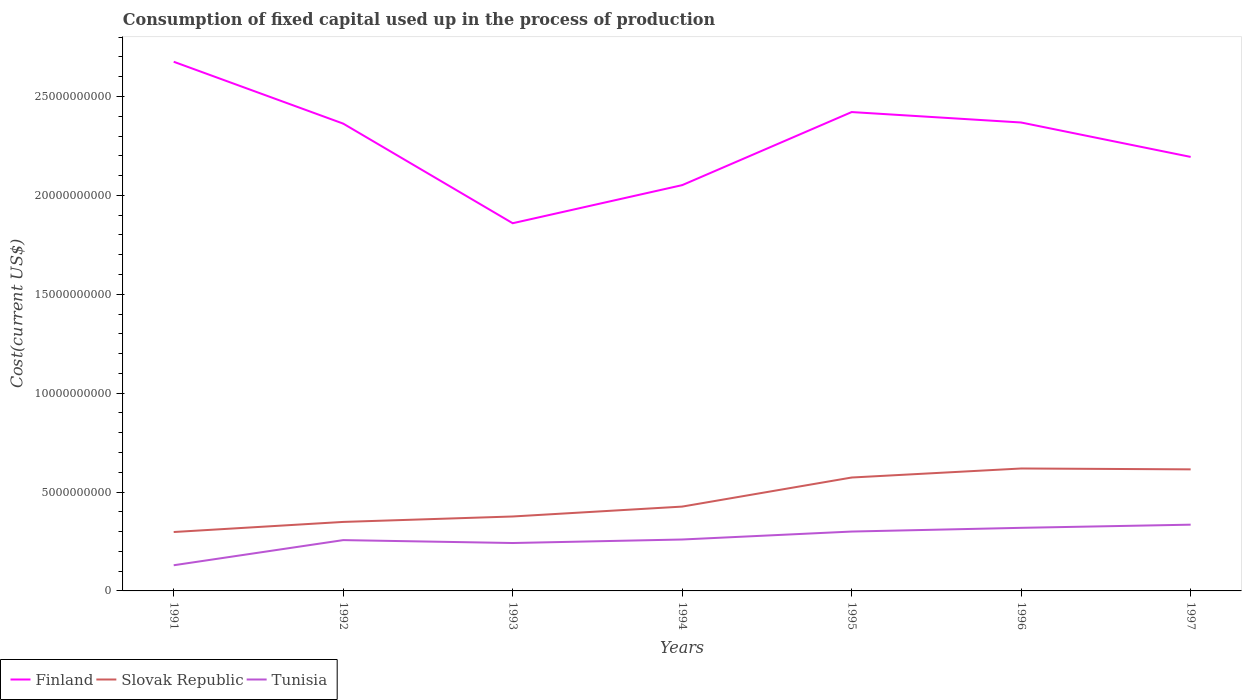Across all years, what is the maximum amount consumed in the process of production in Finland?
Your answer should be compact. 1.86e+1. What is the total amount consumed in the process of production in Finland in the graph?
Offer a terse response. -5.59e+07. What is the difference between the highest and the second highest amount consumed in the process of production in Slovak Republic?
Keep it short and to the point. 3.21e+09. Is the amount consumed in the process of production in Finland strictly greater than the amount consumed in the process of production in Tunisia over the years?
Give a very brief answer. No. What is the difference between two consecutive major ticks on the Y-axis?
Provide a succinct answer. 5.00e+09. Are the values on the major ticks of Y-axis written in scientific E-notation?
Your answer should be compact. No. How many legend labels are there?
Your answer should be compact. 3. How are the legend labels stacked?
Your response must be concise. Horizontal. What is the title of the graph?
Your response must be concise. Consumption of fixed capital used up in the process of production. What is the label or title of the Y-axis?
Provide a succinct answer. Cost(current US$). What is the Cost(current US$) in Finland in 1991?
Offer a terse response. 2.68e+1. What is the Cost(current US$) of Slovak Republic in 1991?
Your response must be concise. 2.98e+09. What is the Cost(current US$) of Tunisia in 1991?
Make the answer very short. 1.30e+09. What is the Cost(current US$) of Finland in 1992?
Ensure brevity in your answer.  2.36e+1. What is the Cost(current US$) in Slovak Republic in 1992?
Give a very brief answer. 3.49e+09. What is the Cost(current US$) of Tunisia in 1992?
Your answer should be very brief. 2.57e+09. What is the Cost(current US$) in Finland in 1993?
Provide a succinct answer. 1.86e+1. What is the Cost(current US$) in Slovak Republic in 1993?
Provide a short and direct response. 3.76e+09. What is the Cost(current US$) of Tunisia in 1993?
Offer a very short reply. 2.42e+09. What is the Cost(current US$) of Finland in 1994?
Make the answer very short. 2.05e+1. What is the Cost(current US$) of Slovak Republic in 1994?
Your answer should be compact. 4.26e+09. What is the Cost(current US$) of Tunisia in 1994?
Offer a terse response. 2.60e+09. What is the Cost(current US$) of Finland in 1995?
Make the answer very short. 2.42e+1. What is the Cost(current US$) in Slovak Republic in 1995?
Your answer should be very brief. 5.73e+09. What is the Cost(current US$) in Tunisia in 1995?
Give a very brief answer. 3.00e+09. What is the Cost(current US$) in Finland in 1996?
Offer a very short reply. 2.37e+1. What is the Cost(current US$) in Slovak Republic in 1996?
Your answer should be very brief. 6.19e+09. What is the Cost(current US$) in Tunisia in 1996?
Offer a terse response. 3.19e+09. What is the Cost(current US$) in Finland in 1997?
Keep it short and to the point. 2.19e+1. What is the Cost(current US$) of Slovak Republic in 1997?
Provide a succinct answer. 6.15e+09. What is the Cost(current US$) in Tunisia in 1997?
Provide a succinct answer. 3.35e+09. Across all years, what is the maximum Cost(current US$) in Finland?
Keep it short and to the point. 2.68e+1. Across all years, what is the maximum Cost(current US$) of Slovak Republic?
Your response must be concise. 6.19e+09. Across all years, what is the maximum Cost(current US$) of Tunisia?
Your response must be concise. 3.35e+09. Across all years, what is the minimum Cost(current US$) of Finland?
Give a very brief answer. 1.86e+1. Across all years, what is the minimum Cost(current US$) in Slovak Republic?
Provide a succinct answer. 2.98e+09. Across all years, what is the minimum Cost(current US$) of Tunisia?
Provide a short and direct response. 1.30e+09. What is the total Cost(current US$) of Finland in the graph?
Offer a terse response. 1.59e+11. What is the total Cost(current US$) of Slovak Republic in the graph?
Your response must be concise. 3.26e+1. What is the total Cost(current US$) of Tunisia in the graph?
Offer a very short reply. 1.84e+1. What is the difference between the Cost(current US$) in Finland in 1991 and that in 1992?
Offer a very short reply. 3.13e+09. What is the difference between the Cost(current US$) in Slovak Republic in 1991 and that in 1992?
Your response must be concise. -5.11e+08. What is the difference between the Cost(current US$) in Tunisia in 1991 and that in 1992?
Offer a very short reply. -1.27e+09. What is the difference between the Cost(current US$) in Finland in 1991 and that in 1993?
Offer a very short reply. 8.16e+09. What is the difference between the Cost(current US$) of Slovak Republic in 1991 and that in 1993?
Your answer should be compact. -7.86e+08. What is the difference between the Cost(current US$) in Tunisia in 1991 and that in 1993?
Provide a short and direct response. -1.12e+09. What is the difference between the Cost(current US$) in Finland in 1991 and that in 1994?
Your response must be concise. 6.24e+09. What is the difference between the Cost(current US$) in Slovak Republic in 1991 and that in 1994?
Offer a terse response. -1.29e+09. What is the difference between the Cost(current US$) in Tunisia in 1991 and that in 1994?
Ensure brevity in your answer.  -1.30e+09. What is the difference between the Cost(current US$) in Finland in 1991 and that in 1995?
Make the answer very short. 2.54e+09. What is the difference between the Cost(current US$) in Slovak Republic in 1991 and that in 1995?
Your response must be concise. -2.76e+09. What is the difference between the Cost(current US$) in Tunisia in 1991 and that in 1995?
Ensure brevity in your answer.  -1.70e+09. What is the difference between the Cost(current US$) in Finland in 1991 and that in 1996?
Give a very brief answer. 3.07e+09. What is the difference between the Cost(current US$) of Slovak Republic in 1991 and that in 1996?
Keep it short and to the point. -3.21e+09. What is the difference between the Cost(current US$) of Tunisia in 1991 and that in 1996?
Give a very brief answer. -1.89e+09. What is the difference between the Cost(current US$) of Finland in 1991 and that in 1997?
Your response must be concise. 4.81e+09. What is the difference between the Cost(current US$) of Slovak Republic in 1991 and that in 1997?
Offer a terse response. -3.17e+09. What is the difference between the Cost(current US$) of Tunisia in 1991 and that in 1997?
Your answer should be very brief. -2.05e+09. What is the difference between the Cost(current US$) in Finland in 1992 and that in 1993?
Provide a succinct answer. 5.04e+09. What is the difference between the Cost(current US$) of Slovak Republic in 1992 and that in 1993?
Your answer should be compact. -2.75e+08. What is the difference between the Cost(current US$) of Tunisia in 1992 and that in 1993?
Give a very brief answer. 1.47e+08. What is the difference between the Cost(current US$) of Finland in 1992 and that in 1994?
Your answer should be compact. 3.11e+09. What is the difference between the Cost(current US$) of Slovak Republic in 1992 and that in 1994?
Ensure brevity in your answer.  -7.75e+08. What is the difference between the Cost(current US$) in Tunisia in 1992 and that in 1994?
Keep it short and to the point. -3.14e+07. What is the difference between the Cost(current US$) of Finland in 1992 and that in 1995?
Your answer should be compact. -5.84e+08. What is the difference between the Cost(current US$) in Slovak Republic in 1992 and that in 1995?
Ensure brevity in your answer.  -2.25e+09. What is the difference between the Cost(current US$) of Tunisia in 1992 and that in 1995?
Give a very brief answer. -4.33e+08. What is the difference between the Cost(current US$) in Finland in 1992 and that in 1996?
Your answer should be compact. -5.59e+07. What is the difference between the Cost(current US$) of Slovak Republic in 1992 and that in 1996?
Provide a succinct answer. -2.70e+09. What is the difference between the Cost(current US$) in Tunisia in 1992 and that in 1996?
Keep it short and to the point. -6.21e+08. What is the difference between the Cost(current US$) of Finland in 1992 and that in 1997?
Keep it short and to the point. 1.68e+09. What is the difference between the Cost(current US$) of Slovak Republic in 1992 and that in 1997?
Provide a succinct answer. -2.66e+09. What is the difference between the Cost(current US$) in Tunisia in 1992 and that in 1997?
Ensure brevity in your answer.  -7.81e+08. What is the difference between the Cost(current US$) in Finland in 1993 and that in 1994?
Offer a terse response. -1.93e+09. What is the difference between the Cost(current US$) of Slovak Republic in 1993 and that in 1994?
Your response must be concise. -5.00e+08. What is the difference between the Cost(current US$) of Tunisia in 1993 and that in 1994?
Your response must be concise. -1.78e+08. What is the difference between the Cost(current US$) in Finland in 1993 and that in 1995?
Ensure brevity in your answer.  -5.62e+09. What is the difference between the Cost(current US$) in Slovak Republic in 1993 and that in 1995?
Your answer should be very brief. -1.97e+09. What is the difference between the Cost(current US$) in Tunisia in 1993 and that in 1995?
Provide a short and direct response. -5.80e+08. What is the difference between the Cost(current US$) of Finland in 1993 and that in 1996?
Your answer should be compact. -5.09e+09. What is the difference between the Cost(current US$) of Slovak Republic in 1993 and that in 1996?
Give a very brief answer. -2.43e+09. What is the difference between the Cost(current US$) in Tunisia in 1993 and that in 1996?
Offer a very short reply. -7.68e+08. What is the difference between the Cost(current US$) in Finland in 1993 and that in 1997?
Provide a succinct answer. -3.35e+09. What is the difference between the Cost(current US$) of Slovak Republic in 1993 and that in 1997?
Keep it short and to the point. -2.38e+09. What is the difference between the Cost(current US$) in Tunisia in 1993 and that in 1997?
Offer a very short reply. -9.28e+08. What is the difference between the Cost(current US$) in Finland in 1994 and that in 1995?
Offer a very short reply. -3.69e+09. What is the difference between the Cost(current US$) in Slovak Republic in 1994 and that in 1995?
Your answer should be very brief. -1.47e+09. What is the difference between the Cost(current US$) in Tunisia in 1994 and that in 1995?
Keep it short and to the point. -4.02e+08. What is the difference between the Cost(current US$) in Finland in 1994 and that in 1996?
Ensure brevity in your answer.  -3.17e+09. What is the difference between the Cost(current US$) in Slovak Republic in 1994 and that in 1996?
Offer a very short reply. -1.93e+09. What is the difference between the Cost(current US$) in Tunisia in 1994 and that in 1996?
Your answer should be compact. -5.90e+08. What is the difference between the Cost(current US$) of Finland in 1994 and that in 1997?
Offer a terse response. -1.43e+09. What is the difference between the Cost(current US$) in Slovak Republic in 1994 and that in 1997?
Make the answer very short. -1.88e+09. What is the difference between the Cost(current US$) in Tunisia in 1994 and that in 1997?
Provide a short and direct response. -7.49e+08. What is the difference between the Cost(current US$) in Finland in 1995 and that in 1996?
Provide a succinct answer. 5.28e+08. What is the difference between the Cost(current US$) in Slovak Republic in 1995 and that in 1996?
Offer a terse response. -4.56e+08. What is the difference between the Cost(current US$) of Tunisia in 1995 and that in 1996?
Offer a terse response. -1.88e+08. What is the difference between the Cost(current US$) of Finland in 1995 and that in 1997?
Your answer should be very brief. 2.27e+09. What is the difference between the Cost(current US$) of Slovak Republic in 1995 and that in 1997?
Ensure brevity in your answer.  -4.12e+08. What is the difference between the Cost(current US$) of Tunisia in 1995 and that in 1997?
Make the answer very short. -3.47e+08. What is the difference between the Cost(current US$) in Finland in 1996 and that in 1997?
Your response must be concise. 1.74e+09. What is the difference between the Cost(current US$) of Slovak Republic in 1996 and that in 1997?
Ensure brevity in your answer.  4.36e+07. What is the difference between the Cost(current US$) of Tunisia in 1996 and that in 1997?
Your answer should be compact. -1.59e+08. What is the difference between the Cost(current US$) in Finland in 1991 and the Cost(current US$) in Slovak Republic in 1992?
Make the answer very short. 2.33e+1. What is the difference between the Cost(current US$) in Finland in 1991 and the Cost(current US$) in Tunisia in 1992?
Keep it short and to the point. 2.42e+1. What is the difference between the Cost(current US$) of Slovak Republic in 1991 and the Cost(current US$) of Tunisia in 1992?
Your answer should be compact. 4.09e+08. What is the difference between the Cost(current US$) of Finland in 1991 and the Cost(current US$) of Slovak Republic in 1993?
Make the answer very short. 2.30e+1. What is the difference between the Cost(current US$) in Finland in 1991 and the Cost(current US$) in Tunisia in 1993?
Make the answer very short. 2.43e+1. What is the difference between the Cost(current US$) in Slovak Republic in 1991 and the Cost(current US$) in Tunisia in 1993?
Offer a very short reply. 5.56e+08. What is the difference between the Cost(current US$) in Finland in 1991 and the Cost(current US$) in Slovak Republic in 1994?
Offer a terse response. 2.25e+1. What is the difference between the Cost(current US$) of Finland in 1991 and the Cost(current US$) of Tunisia in 1994?
Provide a succinct answer. 2.42e+1. What is the difference between the Cost(current US$) of Slovak Republic in 1991 and the Cost(current US$) of Tunisia in 1994?
Your answer should be compact. 3.78e+08. What is the difference between the Cost(current US$) of Finland in 1991 and the Cost(current US$) of Slovak Republic in 1995?
Make the answer very short. 2.10e+1. What is the difference between the Cost(current US$) in Finland in 1991 and the Cost(current US$) in Tunisia in 1995?
Offer a terse response. 2.38e+1. What is the difference between the Cost(current US$) of Slovak Republic in 1991 and the Cost(current US$) of Tunisia in 1995?
Give a very brief answer. -2.42e+07. What is the difference between the Cost(current US$) in Finland in 1991 and the Cost(current US$) in Slovak Republic in 1996?
Your answer should be compact. 2.06e+1. What is the difference between the Cost(current US$) of Finland in 1991 and the Cost(current US$) of Tunisia in 1996?
Your answer should be very brief. 2.36e+1. What is the difference between the Cost(current US$) of Slovak Republic in 1991 and the Cost(current US$) of Tunisia in 1996?
Give a very brief answer. -2.12e+08. What is the difference between the Cost(current US$) in Finland in 1991 and the Cost(current US$) in Slovak Republic in 1997?
Offer a terse response. 2.06e+1. What is the difference between the Cost(current US$) of Finland in 1991 and the Cost(current US$) of Tunisia in 1997?
Provide a succinct answer. 2.34e+1. What is the difference between the Cost(current US$) in Slovak Republic in 1991 and the Cost(current US$) in Tunisia in 1997?
Ensure brevity in your answer.  -3.71e+08. What is the difference between the Cost(current US$) of Finland in 1992 and the Cost(current US$) of Slovak Republic in 1993?
Make the answer very short. 1.99e+1. What is the difference between the Cost(current US$) of Finland in 1992 and the Cost(current US$) of Tunisia in 1993?
Make the answer very short. 2.12e+1. What is the difference between the Cost(current US$) in Slovak Republic in 1992 and the Cost(current US$) in Tunisia in 1993?
Ensure brevity in your answer.  1.07e+09. What is the difference between the Cost(current US$) of Finland in 1992 and the Cost(current US$) of Slovak Republic in 1994?
Offer a very short reply. 1.94e+1. What is the difference between the Cost(current US$) in Finland in 1992 and the Cost(current US$) in Tunisia in 1994?
Your answer should be very brief. 2.10e+1. What is the difference between the Cost(current US$) of Slovak Republic in 1992 and the Cost(current US$) of Tunisia in 1994?
Your answer should be compact. 8.88e+08. What is the difference between the Cost(current US$) of Finland in 1992 and the Cost(current US$) of Slovak Republic in 1995?
Give a very brief answer. 1.79e+1. What is the difference between the Cost(current US$) of Finland in 1992 and the Cost(current US$) of Tunisia in 1995?
Ensure brevity in your answer.  2.06e+1. What is the difference between the Cost(current US$) in Slovak Republic in 1992 and the Cost(current US$) in Tunisia in 1995?
Your answer should be very brief. 4.86e+08. What is the difference between the Cost(current US$) of Finland in 1992 and the Cost(current US$) of Slovak Republic in 1996?
Provide a short and direct response. 1.74e+1. What is the difference between the Cost(current US$) in Finland in 1992 and the Cost(current US$) in Tunisia in 1996?
Your answer should be very brief. 2.04e+1. What is the difference between the Cost(current US$) of Slovak Republic in 1992 and the Cost(current US$) of Tunisia in 1996?
Provide a short and direct response. 2.99e+08. What is the difference between the Cost(current US$) in Finland in 1992 and the Cost(current US$) in Slovak Republic in 1997?
Ensure brevity in your answer.  1.75e+1. What is the difference between the Cost(current US$) in Finland in 1992 and the Cost(current US$) in Tunisia in 1997?
Give a very brief answer. 2.03e+1. What is the difference between the Cost(current US$) in Slovak Republic in 1992 and the Cost(current US$) in Tunisia in 1997?
Your response must be concise. 1.39e+08. What is the difference between the Cost(current US$) in Finland in 1993 and the Cost(current US$) in Slovak Republic in 1994?
Provide a short and direct response. 1.43e+1. What is the difference between the Cost(current US$) in Finland in 1993 and the Cost(current US$) in Tunisia in 1994?
Your answer should be compact. 1.60e+1. What is the difference between the Cost(current US$) in Slovak Republic in 1993 and the Cost(current US$) in Tunisia in 1994?
Offer a very short reply. 1.16e+09. What is the difference between the Cost(current US$) of Finland in 1993 and the Cost(current US$) of Slovak Republic in 1995?
Your answer should be very brief. 1.29e+1. What is the difference between the Cost(current US$) of Finland in 1993 and the Cost(current US$) of Tunisia in 1995?
Make the answer very short. 1.56e+1. What is the difference between the Cost(current US$) of Slovak Republic in 1993 and the Cost(current US$) of Tunisia in 1995?
Your response must be concise. 7.62e+08. What is the difference between the Cost(current US$) of Finland in 1993 and the Cost(current US$) of Slovak Republic in 1996?
Your answer should be very brief. 1.24e+1. What is the difference between the Cost(current US$) of Finland in 1993 and the Cost(current US$) of Tunisia in 1996?
Your answer should be very brief. 1.54e+1. What is the difference between the Cost(current US$) in Slovak Republic in 1993 and the Cost(current US$) in Tunisia in 1996?
Offer a terse response. 5.74e+08. What is the difference between the Cost(current US$) of Finland in 1993 and the Cost(current US$) of Slovak Republic in 1997?
Your answer should be compact. 1.24e+1. What is the difference between the Cost(current US$) in Finland in 1993 and the Cost(current US$) in Tunisia in 1997?
Provide a succinct answer. 1.52e+1. What is the difference between the Cost(current US$) in Slovak Republic in 1993 and the Cost(current US$) in Tunisia in 1997?
Give a very brief answer. 4.14e+08. What is the difference between the Cost(current US$) in Finland in 1994 and the Cost(current US$) in Slovak Republic in 1995?
Your response must be concise. 1.48e+1. What is the difference between the Cost(current US$) in Finland in 1994 and the Cost(current US$) in Tunisia in 1995?
Make the answer very short. 1.75e+1. What is the difference between the Cost(current US$) of Slovak Republic in 1994 and the Cost(current US$) of Tunisia in 1995?
Make the answer very short. 1.26e+09. What is the difference between the Cost(current US$) of Finland in 1994 and the Cost(current US$) of Slovak Republic in 1996?
Ensure brevity in your answer.  1.43e+1. What is the difference between the Cost(current US$) in Finland in 1994 and the Cost(current US$) in Tunisia in 1996?
Make the answer very short. 1.73e+1. What is the difference between the Cost(current US$) of Slovak Republic in 1994 and the Cost(current US$) of Tunisia in 1996?
Keep it short and to the point. 1.07e+09. What is the difference between the Cost(current US$) of Finland in 1994 and the Cost(current US$) of Slovak Republic in 1997?
Ensure brevity in your answer.  1.44e+1. What is the difference between the Cost(current US$) of Finland in 1994 and the Cost(current US$) of Tunisia in 1997?
Offer a terse response. 1.72e+1. What is the difference between the Cost(current US$) of Slovak Republic in 1994 and the Cost(current US$) of Tunisia in 1997?
Give a very brief answer. 9.14e+08. What is the difference between the Cost(current US$) in Finland in 1995 and the Cost(current US$) in Slovak Republic in 1996?
Your answer should be very brief. 1.80e+1. What is the difference between the Cost(current US$) of Finland in 1995 and the Cost(current US$) of Tunisia in 1996?
Make the answer very short. 2.10e+1. What is the difference between the Cost(current US$) of Slovak Republic in 1995 and the Cost(current US$) of Tunisia in 1996?
Make the answer very short. 2.54e+09. What is the difference between the Cost(current US$) in Finland in 1995 and the Cost(current US$) in Slovak Republic in 1997?
Provide a short and direct response. 1.81e+1. What is the difference between the Cost(current US$) in Finland in 1995 and the Cost(current US$) in Tunisia in 1997?
Offer a very short reply. 2.09e+1. What is the difference between the Cost(current US$) in Slovak Republic in 1995 and the Cost(current US$) in Tunisia in 1997?
Your answer should be very brief. 2.38e+09. What is the difference between the Cost(current US$) of Finland in 1996 and the Cost(current US$) of Slovak Republic in 1997?
Provide a short and direct response. 1.75e+1. What is the difference between the Cost(current US$) in Finland in 1996 and the Cost(current US$) in Tunisia in 1997?
Offer a terse response. 2.03e+1. What is the difference between the Cost(current US$) in Slovak Republic in 1996 and the Cost(current US$) in Tunisia in 1997?
Give a very brief answer. 2.84e+09. What is the average Cost(current US$) in Finland per year?
Your answer should be compact. 2.28e+1. What is the average Cost(current US$) of Slovak Republic per year?
Your response must be concise. 4.65e+09. What is the average Cost(current US$) of Tunisia per year?
Keep it short and to the point. 2.63e+09. In the year 1991, what is the difference between the Cost(current US$) in Finland and Cost(current US$) in Slovak Republic?
Offer a very short reply. 2.38e+1. In the year 1991, what is the difference between the Cost(current US$) in Finland and Cost(current US$) in Tunisia?
Keep it short and to the point. 2.55e+1. In the year 1991, what is the difference between the Cost(current US$) in Slovak Republic and Cost(current US$) in Tunisia?
Ensure brevity in your answer.  1.68e+09. In the year 1992, what is the difference between the Cost(current US$) of Finland and Cost(current US$) of Slovak Republic?
Make the answer very short. 2.01e+1. In the year 1992, what is the difference between the Cost(current US$) in Finland and Cost(current US$) in Tunisia?
Provide a succinct answer. 2.11e+1. In the year 1992, what is the difference between the Cost(current US$) of Slovak Republic and Cost(current US$) of Tunisia?
Offer a very short reply. 9.20e+08. In the year 1993, what is the difference between the Cost(current US$) of Finland and Cost(current US$) of Slovak Republic?
Provide a succinct answer. 1.48e+1. In the year 1993, what is the difference between the Cost(current US$) in Finland and Cost(current US$) in Tunisia?
Make the answer very short. 1.62e+1. In the year 1993, what is the difference between the Cost(current US$) of Slovak Republic and Cost(current US$) of Tunisia?
Offer a very short reply. 1.34e+09. In the year 1994, what is the difference between the Cost(current US$) in Finland and Cost(current US$) in Slovak Republic?
Your answer should be compact. 1.63e+1. In the year 1994, what is the difference between the Cost(current US$) in Finland and Cost(current US$) in Tunisia?
Provide a short and direct response. 1.79e+1. In the year 1994, what is the difference between the Cost(current US$) of Slovak Republic and Cost(current US$) of Tunisia?
Your answer should be compact. 1.66e+09. In the year 1995, what is the difference between the Cost(current US$) in Finland and Cost(current US$) in Slovak Republic?
Make the answer very short. 1.85e+1. In the year 1995, what is the difference between the Cost(current US$) of Finland and Cost(current US$) of Tunisia?
Keep it short and to the point. 2.12e+1. In the year 1995, what is the difference between the Cost(current US$) in Slovak Republic and Cost(current US$) in Tunisia?
Your response must be concise. 2.73e+09. In the year 1996, what is the difference between the Cost(current US$) in Finland and Cost(current US$) in Slovak Republic?
Keep it short and to the point. 1.75e+1. In the year 1996, what is the difference between the Cost(current US$) of Finland and Cost(current US$) of Tunisia?
Your response must be concise. 2.05e+1. In the year 1996, what is the difference between the Cost(current US$) in Slovak Republic and Cost(current US$) in Tunisia?
Keep it short and to the point. 3.00e+09. In the year 1997, what is the difference between the Cost(current US$) in Finland and Cost(current US$) in Slovak Republic?
Offer a terse response. 1.58e+1. In the year 1997, what is the difference between the Cost(current US$) in Finland and Cost(current US$) in Tunisia?
Provide a succinct answer. 1.86e+1. In the year 1997, what is the difference between the Cost(current US$) of Slovak Republic and Cost(current US$) of Tunisia?
Your response must be concise. 2.80e+09. What is the ratio of the Cost(current US$) of Finland in 1991 to that in 1992?
Your answer should be compact. 1.13. What is the ratio of the Cost(current US$) in Slovak Republic in 1991 to that in 1992?
Your answer should be compact. 0.85. What is the ratio of the Cost(current US$) of Tunisia in 1991 to that in 1992?
Your answer should be very brief. 0.51. What is the ratio of the Cost(current US$) of Finland in 1991 to that in 1993?
Make the answer very short. 1.44. What is the ratio of the Cost(current US$) in Slovak Republic in 1991 to that in 1993?
Keep it short and to the point. 0.79. What is the ratio of the Cost(current US$) of Tunisia in 1991 to that in 1993?
Ensure brevity in your answer.  0.54. What is the ratio of the Cost(current US$) of Finland in 1991 to that in 1994?
Offer a terse response. 1.3. What is the ratio of the Cost(current US$) in Slovak Republic in 1991 to that in 1994?
Make the answer very short. 0.7. What is the ratio of the Cost(current US$) in Tunisia in 1991 to that in 1994?
Your response must be concise. 0.5. What is the ratio of the Cost(current US$) in Finland in 1991 to that in 1995?
Make the answer very short. 1.11. What is the ratio of the Cost(current US$) of Slovak Republic in 1991 to that in 1995?
Make the answer very short. 0.52. What is the ratio of the Cost(current US$) of Tunisia in 1991 to that in 1995?
Your answer should be compact. 0.43. What is the ratio of the Cost(current US$) in Finland in 1991 to that in 1996?
Ensure brevity in your answer.  1.13. What is the ratio of the Cost(current US$) in Slovak Republic in 1991 to that in 1996?
Your answer should be very brief. 0.48. What is the ratio of the Cost(current US$) of Tunisia in 1991 to that in 1996?
Keep it short and to the point. 0.41. What is the ratio of the Cost(current US$) in Finland in 1991 to that in 1997?
Offer a very short reply. 1.22. What is the ratio of the Cost(current US$) in Slovak Republic in 1991 to that in 1997?
Keep it short and to the point. 0.48. What is the ratio of the Cost(current US$) of Tunisia in 1991 to that in 1997?
Give a very brief answer. 0.39. What is the ratio of the Cost(current US$) in Finland in 1992 to that in 1993?
Your answer should be very brief. 1.27. What is the ratio of the Cost(current US$) in Slovak Republic in 1992 to that in 1993?
Give a very brief answer. 0.93. What is the ratio of the Cost(current US$) of Tunisia in 1992 to that in 1993?
Ensure brevity in your answer.  1.06. What is the ratio of the Cost(current US$) of Finland in 1992 to that in 1994?
Your answer should be very brief. 1.15. What is the ratio of the Cost(current US$) in Slovak Republic in 1992 to that in 1994?
Provide a short and direct response. 0.82. What is the ratio of the Cost(current US$) of Tunisia in 1992 to that in 1994?
Your answer should be very brief. 0.99. What is the ratio of the Cost(current US$) in Finland in 1992 to that in 1995?
Ensure brevity in your answer.  0.98. What is the ratio of the Cost(current US$) of Slovak Republic in 1992 to that in 1995?
Provide a short and direct response. 0.61. What is the ratio of the Cost(current US$) of Tunisia in 1992 to that in 1995?
Your response must be concise. 0.86. What is the ratio of the Cost(current US$) in Slovak Republic in 1992 to that in 1996?
Your answer should be very brief. 0.56. What is the ratio of the Cost(current US$) in Tunisia in 1992 to that in 1996?
Keep it short and to the point. 0.81. What is the ratio of the Cost(current US$) in Finland in 1992 to that in 1997?
Provide a succinct answer. 1.08. What is the ratio of the Cost(current US$) in Slovak Republic in 1992 to that in 1997?
Make the answer very short. 0.57. What is the ratio of the Cost(current US$) in Tunisia in 1992 to that in 1997?
Keep it short and to the point. 0.77. What is the ratio of the Cost(current US$) in Finland in 1993 to that in 1994?
Keep it short and to the point. 0.91. What is the ratio of the Cost(current US$) in Slovak Republic in 1993 to that in 1994?
Make the answer very short. 0.88. What is the ratio of the Cost(current US$) of Tunisia in 1993 to that in 1994?
Offer a terse response. 0.93. What is the ratio of the Cost(current US$) of Finland in 1993 to that in 1995?
Give a very brief answer. 0.77. What is the ratio of the Cost(current US$) in Slovak Republic in 1993 to that in 1995?
Offer a terse response. 0.66. What is the ratio of the Cost(current US$) of Tunisia in 1993 to that in 1995?
Give a very brief answer. 0.81. What is the ratio of the Cost(current US$) in Finland in 1993 to that in 1996?
Make the answer very short. 0.79. What is the ratio of the Cost(current US$) in Slovak Republic in 1993 to that in 1996?
Provide a short and direct response. 0.61. What is the ratio of the Cost(current US$) of Tunisia in 1993 to that in 1996?
Offer a terse response. 0.76. What is the ratio of the Cost(current US$) of Finland in 1993 to that in 1997?
Give a very brief answer. 0.85. What is the ratio of the Cost(current US$) of Slovak Republic in 1993 to that in 1997?
Offer a terse response. 0.61. What is the ratio of the Cost(current US$) of Tunisia in 1993 to that in 1997?
Provide a short and direct response. 0.72. What is the ratio of the Cost(current US$) in Finland in 1994 to that in 1995?
Provide a short and direct response. 0.85. What is the ratio of the Cost(current US$) in Slovak Republic in 1994 to that in 1995?
Your answer should be compact. 0.74. What is the ratio of the Cost(current US$) in Tunisia in 1994 to that in 1995?
Your answer should be compact. 0.87. What is the ratio of the Cost(current US$) of Finland in 1994 to that in 1996?
Provide a succinct answer. 0.87. What is the ratio of the Cost(current US$) of Slovak Republic in 1994 to that in 1996?
Make the answer very short. 0.69. What is the ratio of the Cost(current US$) in Tunisia in 1994 to that in 1996?
Your answer should be compact. 0.82. What is the ratio of the Cost(current US$) of Finland in 1994 to that in 1997?
Offer a very short reply. 0.94. What is the ratio of the Cost(current US$) of Slovak Republic in 1994 to that in 1997?
Ensure brevity in your answer.  0.69. What is the ratio of the Cost(current US$) of Tunisia in 1994 to that in 1997?
Your response must be concise. 0.78. What is the ratio of the Cost(current US$) of Finland in 1995 to that in 1996?
Make the answer very short. 1.02. What is the ratio of the Cost(current US$) of Slovak Republic in 1995 to that in 1996?
Offer a terse response. 0.93. What is the ratio of the Cost(current US$) in Tunisia in 1995 to that in 1996?
Offer a very short reply. 0.94. What is the ratio of the Cost(current US$) of Finland in 1995 to that in 1997?
Give a very brief answer. 1.1. What is the ratio of the Cost(current US$) in Slovak Republic in 1995 to that in 1997?
Provide a succinct answer. 0.93. What is the ratio of the Cost(current US$) in Tunisia in 1995 to that in 1997?
Give a very brief answer. 0.9. What is the ratio of the Cost(current US$) of Finland in 1996 to that in 1997?
Keep it short and to the point. 1.08. What is the ratio of the Cost(current US$) of Slovak Republic in 1996 to that in 1997?
Give a very brief answer. 1.01. What is the ratio of the Cost(current US$) in Tunisia in 1996 to that in 1997?
Offer a terse response. 0.95. What is the difference between the highest and the second highest Cost(current US$) in Finland?
Keep it short and to the point. 2.54e+09. What is the difference between the highest and the second highest Cost(current US$) in Slovak Republic?
Provide a succinct answer. 4.36e+07. What is the difference between the highest and the second highest Cost(current US$) in Tunisia?
Keep it short and to the point. 1.59e+08. What is the difference between the highest and the lowest Cost(current US$) in Finland?
Your answer should be compact. 8.16e+09. What is the difference between the highest and the lowest Cost(current US$) of Slovak Republic?
Make the answer very short. 3.21e+09. What is the difference between the highest and the lowest Cost(current US$) of Tunisia?
Your answer should be compact. 2.05e+09. 